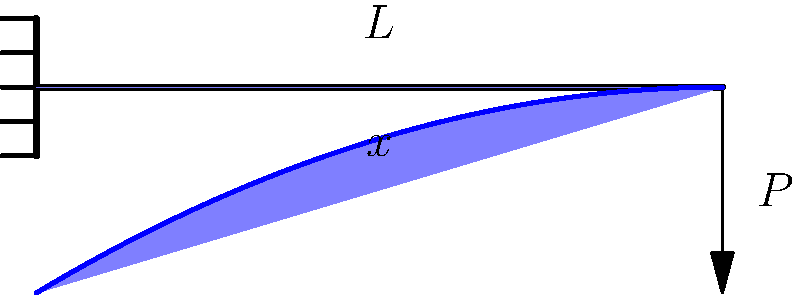In the context of artifact preservation, understanding structural integrity is crucial. Consider a cantilevered beam of length $L$ with a point load $P$ at its free end, as shown in the diagram. How does the bending stress $\sigma$ vary along the length of the beam? Express your answer in terms of $x$, the distance from the fixed end. To determine the bending stress distribution along the cantilevered beam, we'll follow these steps:

1) The bending moment $M$ at any point $x$ along the beam is given by:
   $M(x) = P(L-x)$

2) The bending stress $\sigma$ at any point in the beam's cross-section is given by:
   $\sigma = \frac{My}{I}$
   where $y$ is the distance from the neutral axis and $I$ is the moment of inertia of the cross-section.

3) At the top or bottom surface of the beam, $y$ is constant (let's call it $c$), and $I$ is constant for a uniform beam. Therefore, the stress variation is directly proportional to the moment:
   $\sigma \propto M$

4) Substituting the expression for $M(x)$:
   $\sigma(x) \propto P(L-x)$

5) The maximum stress occurs at the fixed end $(x=0)$ and is proportional to $PL$. We can normalize our expression by this maximum stress:
   $\sigma(x) = \sigma_{max}(1-\frac{x}{L})$

6) The stress varies linearly from $\sigma_{max}$ at $x=0$ to zero at $x=L$.

Therefore, the bending stress distribution along the length of the beam is linear, decreasing from a maximum at the fixed end to zero at the free end.
Answer: $\sigma(x) = \sigma_{max}(1-\frac{x}{L})$ 